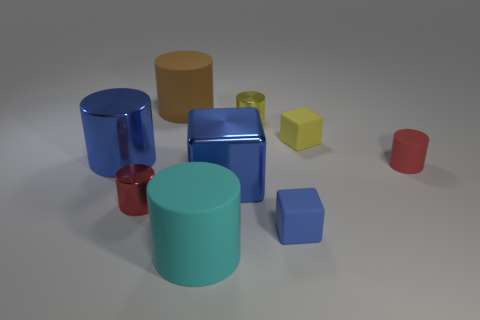Which item seems to stand out the most and why? The blue metallic cylinder stands out due to its bright, reflective surface and vibrant color that contrasts sharply with the more subdued colors and textures of the surrounding objects. 